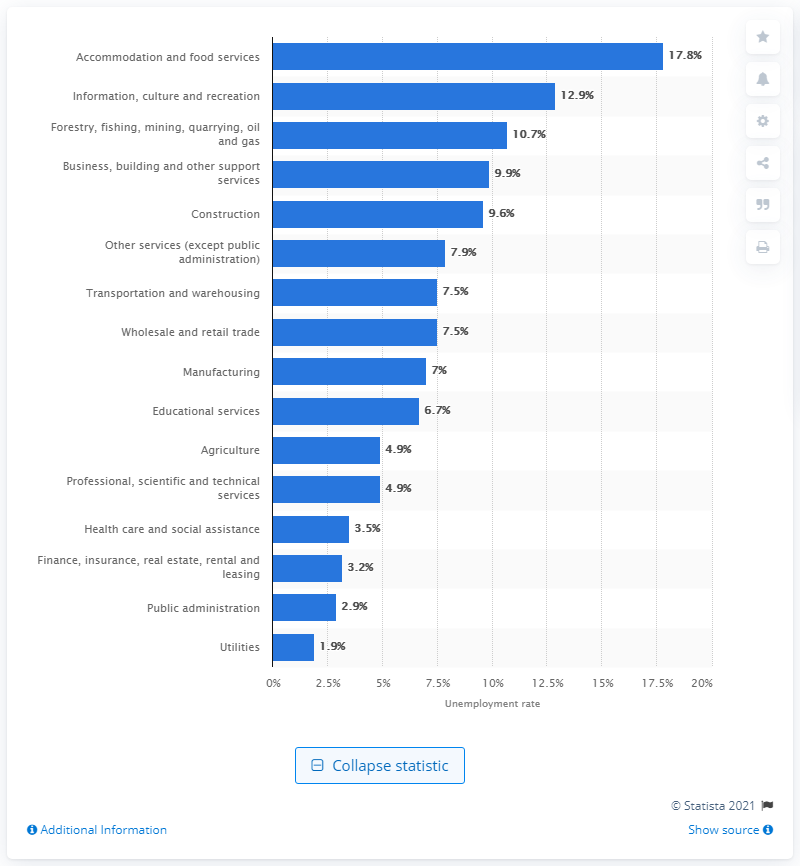Indicate a few pertinent items in this graphic. The agricultural industry in Canada had an unemployment rate of 4.9% in 2020. In 2020, the unemployment rate for the utilities industry in Canada was 1.9%. 